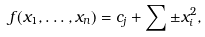Convert formula to latex. <formula><loc_0><loc_0><loc_500><loc_500>f ( x _ { 1 } , \dots , x _ { n } ) = c _ { j } + \sum \pm x _ { i } ^ { 2 } ,</formula> 